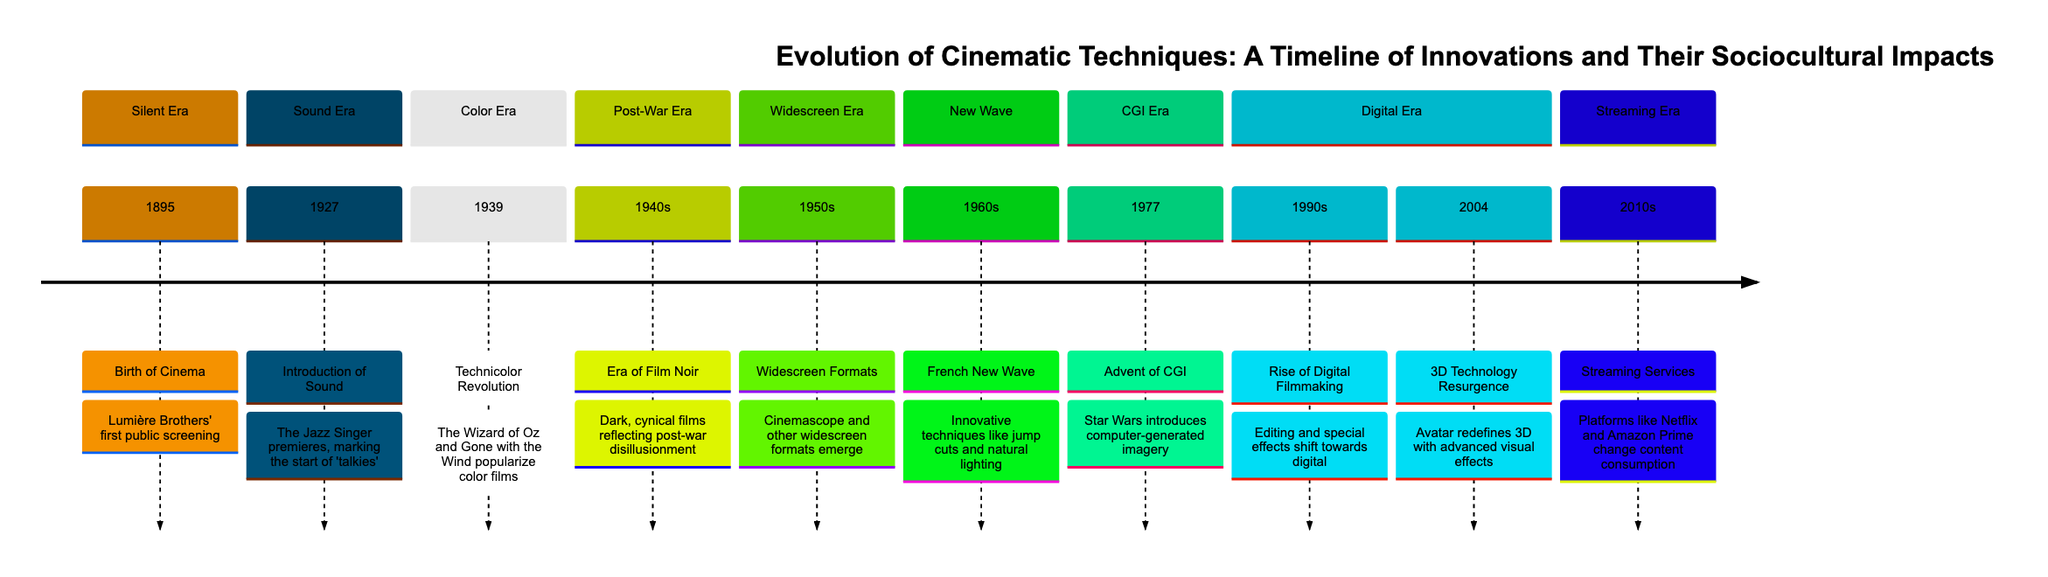What innovation marked the beginning of the Silent Era? The timeline clearly indicates that the Silent Era began in 1895 with the birth of cinema, specifically highlighting the Lumière Brothers' first public screening as the key innovation during this period.
Answer: Birth of Cinema Which film introduced sound in the cinema? According to the section for the Sound Era, it states that "The Jazz Singer" premiered in 1927 as the first film to introduce sound, marking the start of 'talkies'.
Answer: The Jazz Singer What decade is associated with the Color Era in the timeline? The timeline indicates the Color Era, marked by the Technicolor Revolution, occurred in 1939, specifying this year as the critical point of innovation for color films.
Answer: 1930s What were the characteristics of films during the Post-War Era? The timeline describes the Post-War Era by stating that the 1940s experienced the era of film noir, characterized by dark and cynical films that reflect post-war disillusionment, thus explaining the sociocultural impact of that period.
Answer: Era of Film Noir What significant cinematic development occurred in the 1970s? The diagram notes that 1977 marked the advent of CGI with the release of "Star Wars", indicating this was a major innovation in visual effects during this decade.
Answer: Advent of CGI What technique did the French New Wave popularize in the 1960s? The timeline specifies that innovative techniques such as jump cuts and natural lighting were popularized during the French New Wave, highlighting the distinctive cinematic approaches of the 1960s.
Answer: Jump cuts How did digital filmmaking change in the 1990s? The section for the Digital Era suggests that the 1990s saw the rise of digital filmmaking, where editing and special effects shifted towards digital technology, indicating a significant evolution in filmmaking techniques during that period.
Answer: Rise of Digital Filmmaking Which film redefined 3D technology in 2004? The timeline states that in 2004, the film "Avatar" was pivotal in the resurgence of 3D technology, marking an important advancement in visual effects in cinema.
Answer: Avatar What was the impact of streaming services in the 2010s? The diagram notes that streaming services like Netflix and Amazon Prime changed content consumption in the 2010s, highlighting a significant shift in how audiences accessed films and shows.
Answer: Changed content consumption 